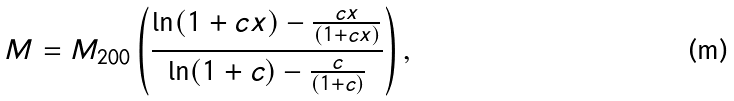Convert formula to latex. <formula><loc_0><loc_0><loc_500><loc_500>M = M _ { 2 0 0 } \left ( \frac { \ln ( 1 + c x ) - \frac { c x } { ( 1 + c x ) } } { \ln ( 1 + c ) - \frac { c } { ( 1 + c ) } } \right ) ,</formula> 